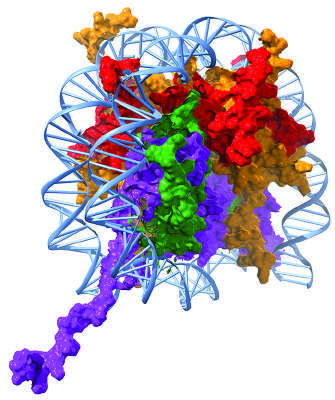re the histone subunits positively charged, thus allowing the compaction of the negatively charged dna?
Answer the question using a single word or phrase. Yes 